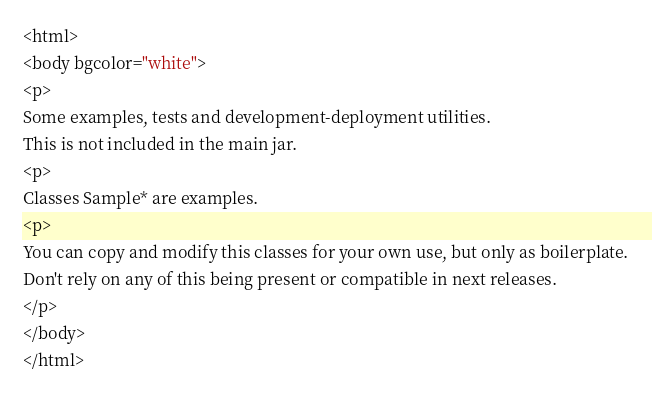Convert code to text. <code><loc_0><loc_0><loc_500><loc_500><_HTML_><html>
<body bgcolor="white">
<p>
Some examples, tests and development-deployment utilities.
This is not included in the main jar. 
<p>
Classes Sample* are examples.
<p>
You can copy and modify this classes for your own use, but only as boilerplate.
Don't rely on any of this being present or compatible in next releases.
</p>
</body>
</html>
</code> 